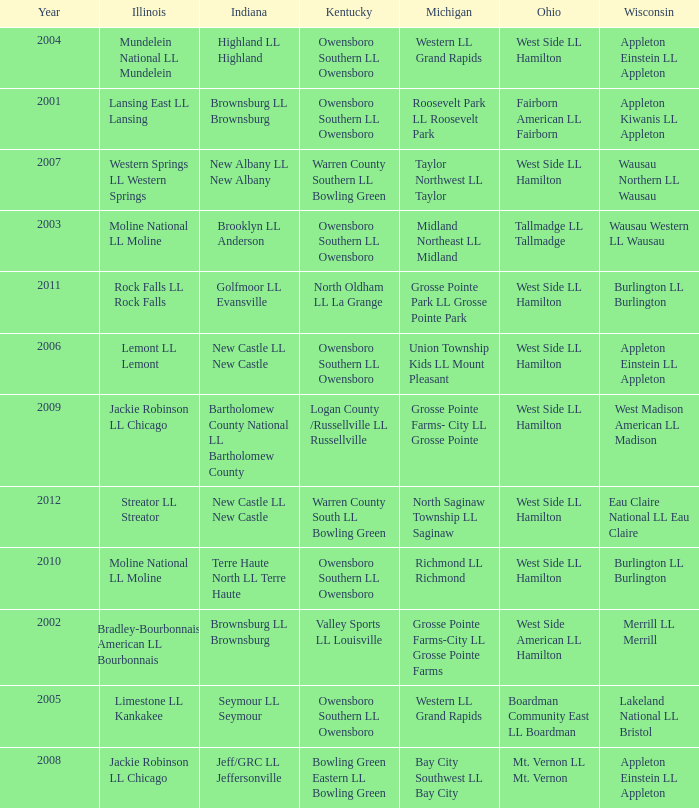What was the little league team from Kentucky when the little league team from Indiana and Wisconsin were Brownsburg LL Brownsburg and Merrill LL Merrill? Valley Sports LL Louisville. 